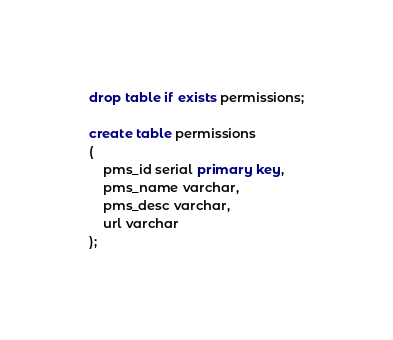<code> <loc_0><loc_0><loc_500><loc_500><_SQL_>drop table if exists permissions;

create table permissions
(
    pms_id serial primary key,
    pms_name varchar,
    pms_desc varchar,
    url varchar
);



</code> 